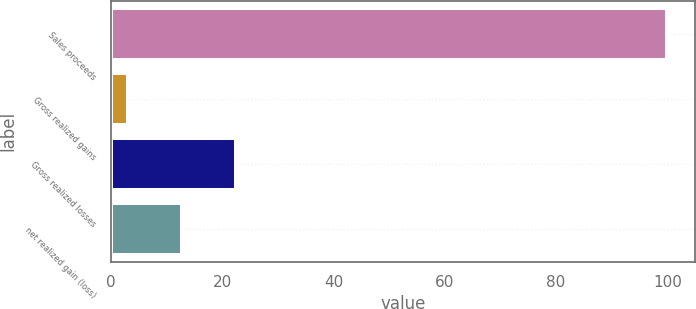Convert chart to OTSL. <chart><loc_0><loc_0><loc_500><loc_500><bar_chart><fcel>Sales proceeds<fcel>Gross realized gains<fcel>Gross realized losses<fcel>net realized gain (loss)<nl><fcel>100<fcel>3<fcel>22.4<fcel>12.7<nl></chart> 